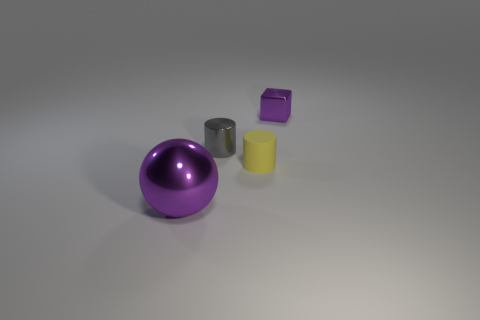Add 4 large red things. How many objects exist? 8 Subtract all yellow cylinders. How many cylinders are left? 1 Subtract all balls. How many objects are left? 3 Subtract 1 balls. How many balls are left? 0 Subtract all red spheres. How many gray blocks are left? 0 Subtract all brown rubber cylinders. Subtract all yellow rubber cylinders. How many objects are left? 3 Add 4 cylinders. How many cylinders are left? 6 Add 1 tiny gray things. How many tiny gray things exist? 2 Subtract 0 brown cylinders. How many objects are left? 4 Subtract all brown spheres. Subtract all red cylinders. How many spheres are left? 1 